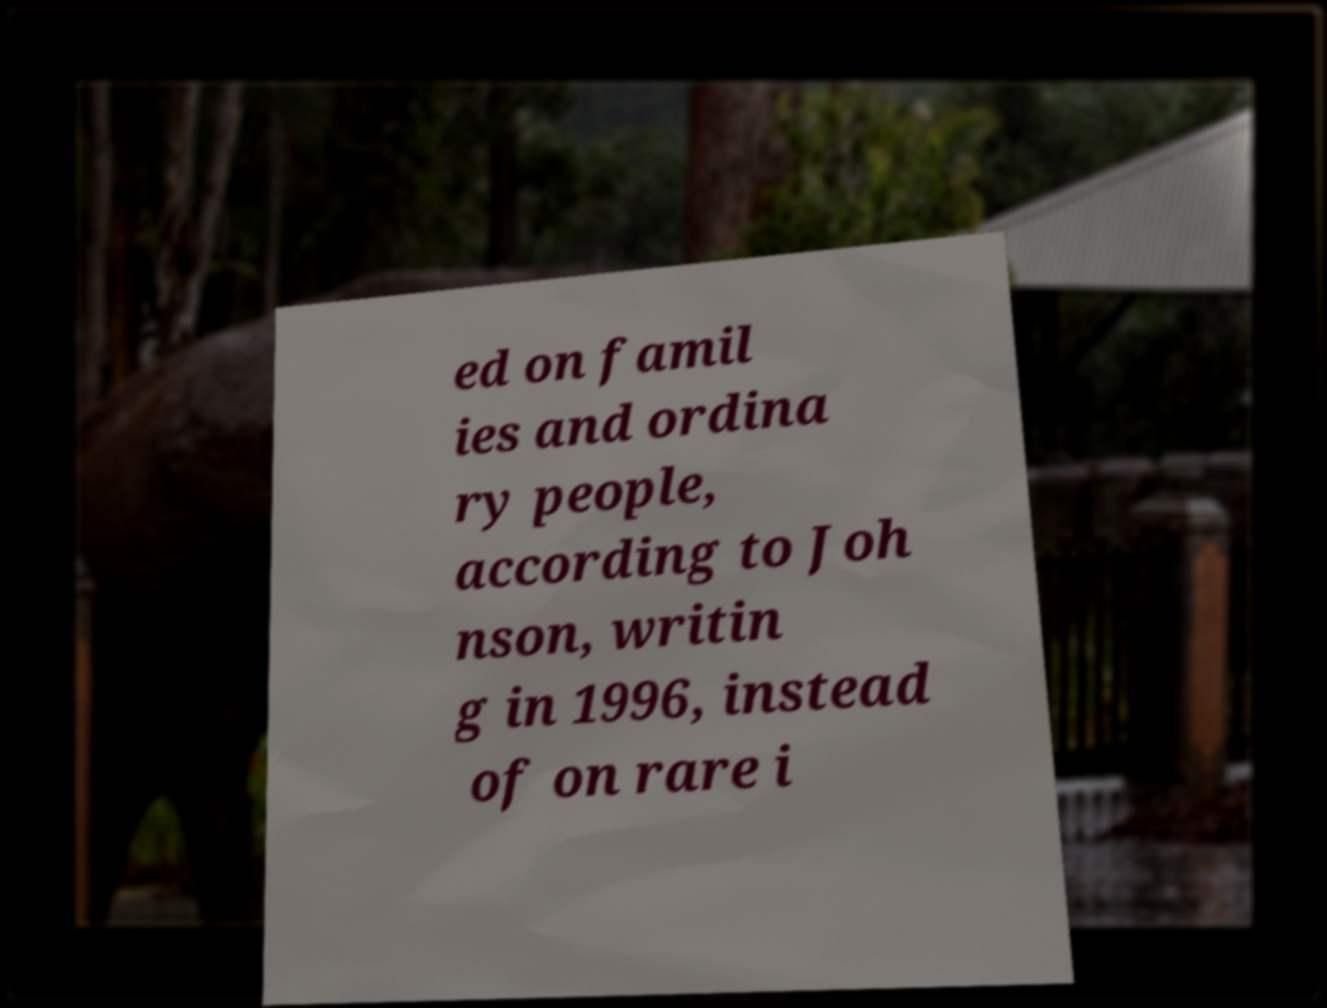There's text embedded in this image that I need extracted. Can you transcribe it verbatim? ed on famil ies and ordina ry people, according to Joh nson, writin g in 1996, instead of on rare i 